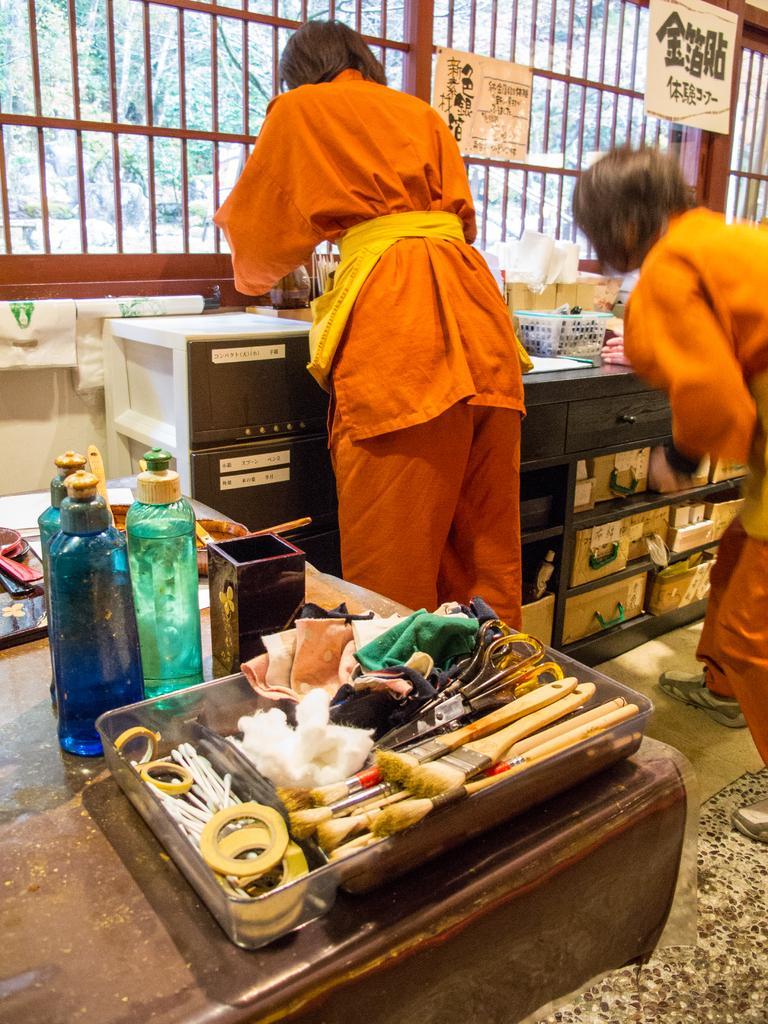How would you summarize this image in a sentence or two? In this image there are few brushes,scissor,cloth,three bottles on a table, two persons are standing and doing some work. At the background i can see a railing and a tree. 